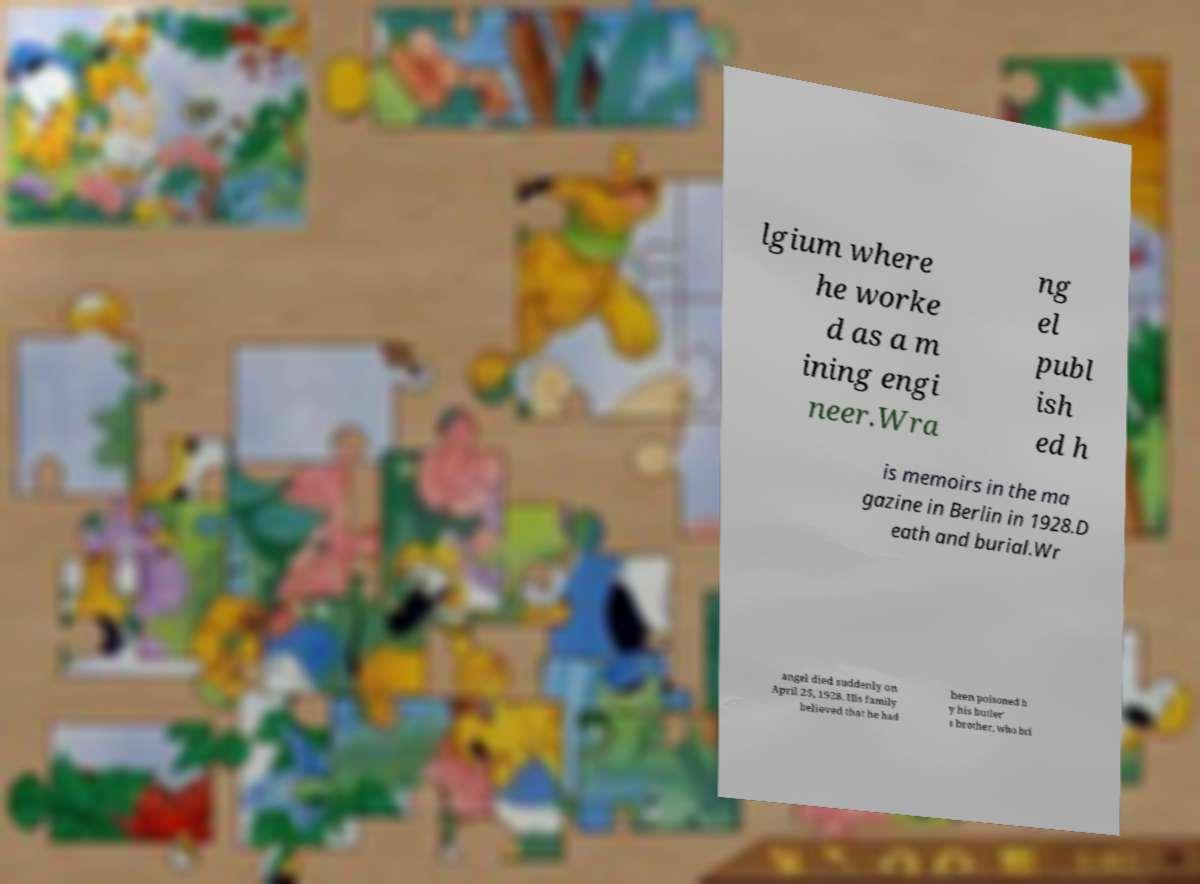Please identify and transcribe the text found in this image. lgium where he worke d as a m ining engi neer.Wra ng el publ ish ed h is memoirs in the ma gazine in Berlin in 1928.D eath and burial.Wr angel died suddenly on April 25, 1928. His family believed that he had been poisoned b y his butler' s brother, who bri 